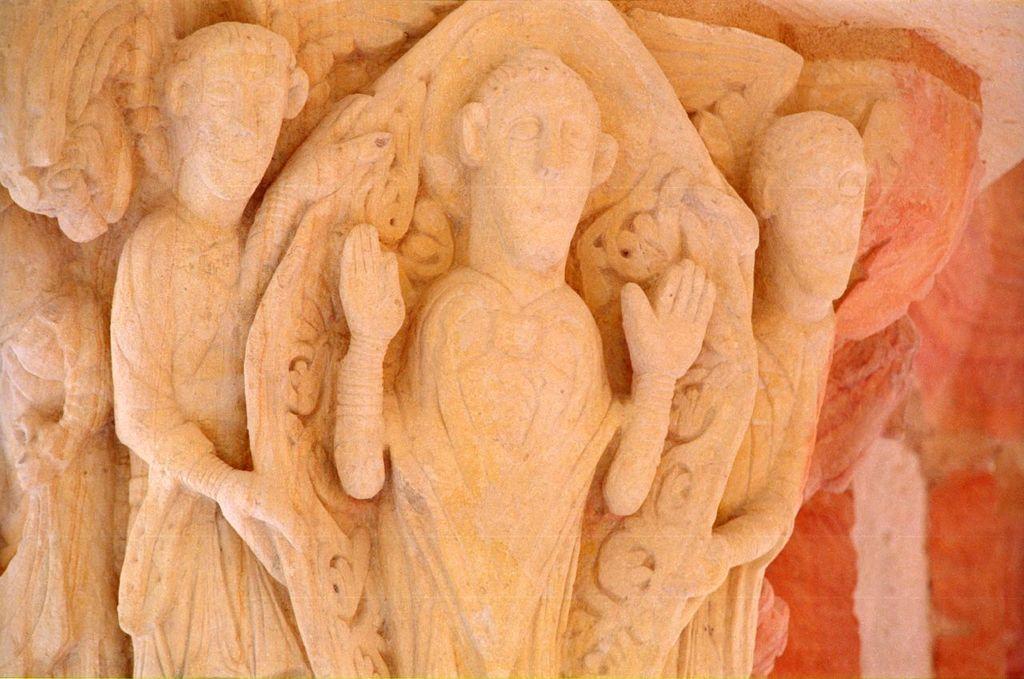How would you summarize this image in a sentence or two? On the left side, there are sculptures on a pillar. And the background is blurred. 